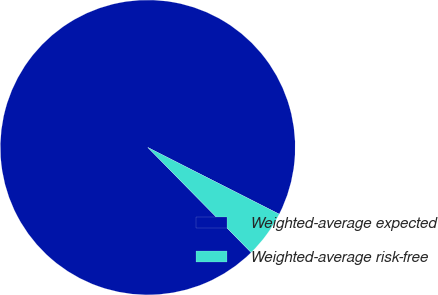Convert chart. <chart><loc_0><loc_0><loc_500><loc_500><pie_chart><fcel>Weighted-average expected<fcel>Weighted-average risk-free<nl><fcel>94.84%<fcel>5.16%<nl></chart> 